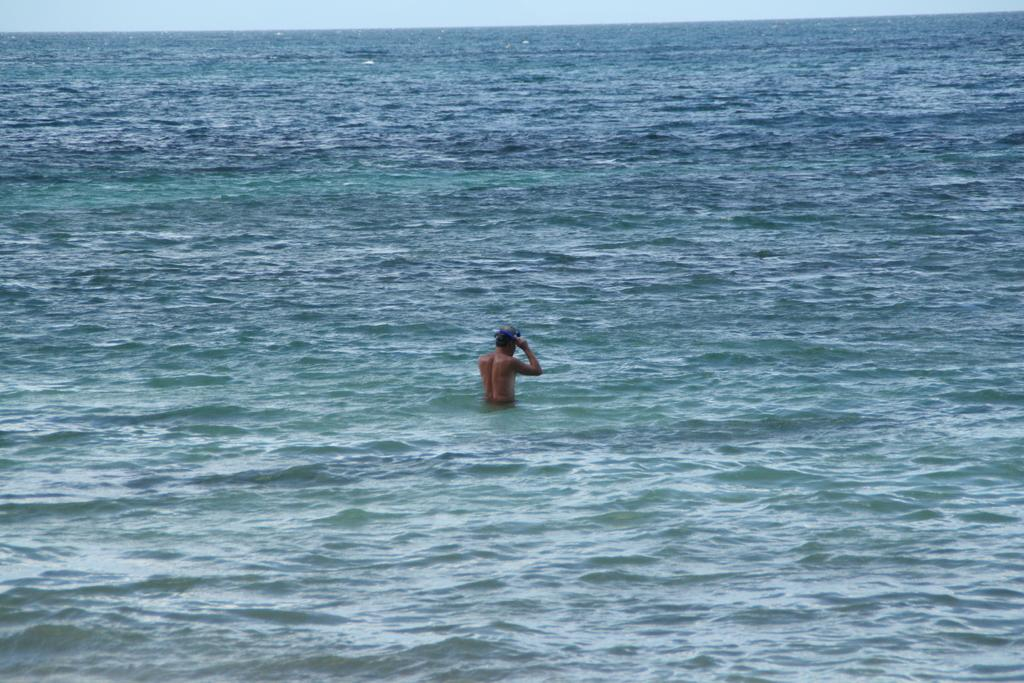What is the main subject of the image? There is a person in the water in the image. Can you describe the person's activity in the image? The person is likely swimming or playing in the water, but the specific activity cannot be determined from the image alone. What type of environment is depicted in the image? The image shows a person in a body of water, which could be a pool, lake, or ocean. Where is the faucet located in the image? There is no faucet present in the image; it only shows a person in the water. What type of house is depicted in the image? There is no house depicted in the image; it only shows a person in the water. 